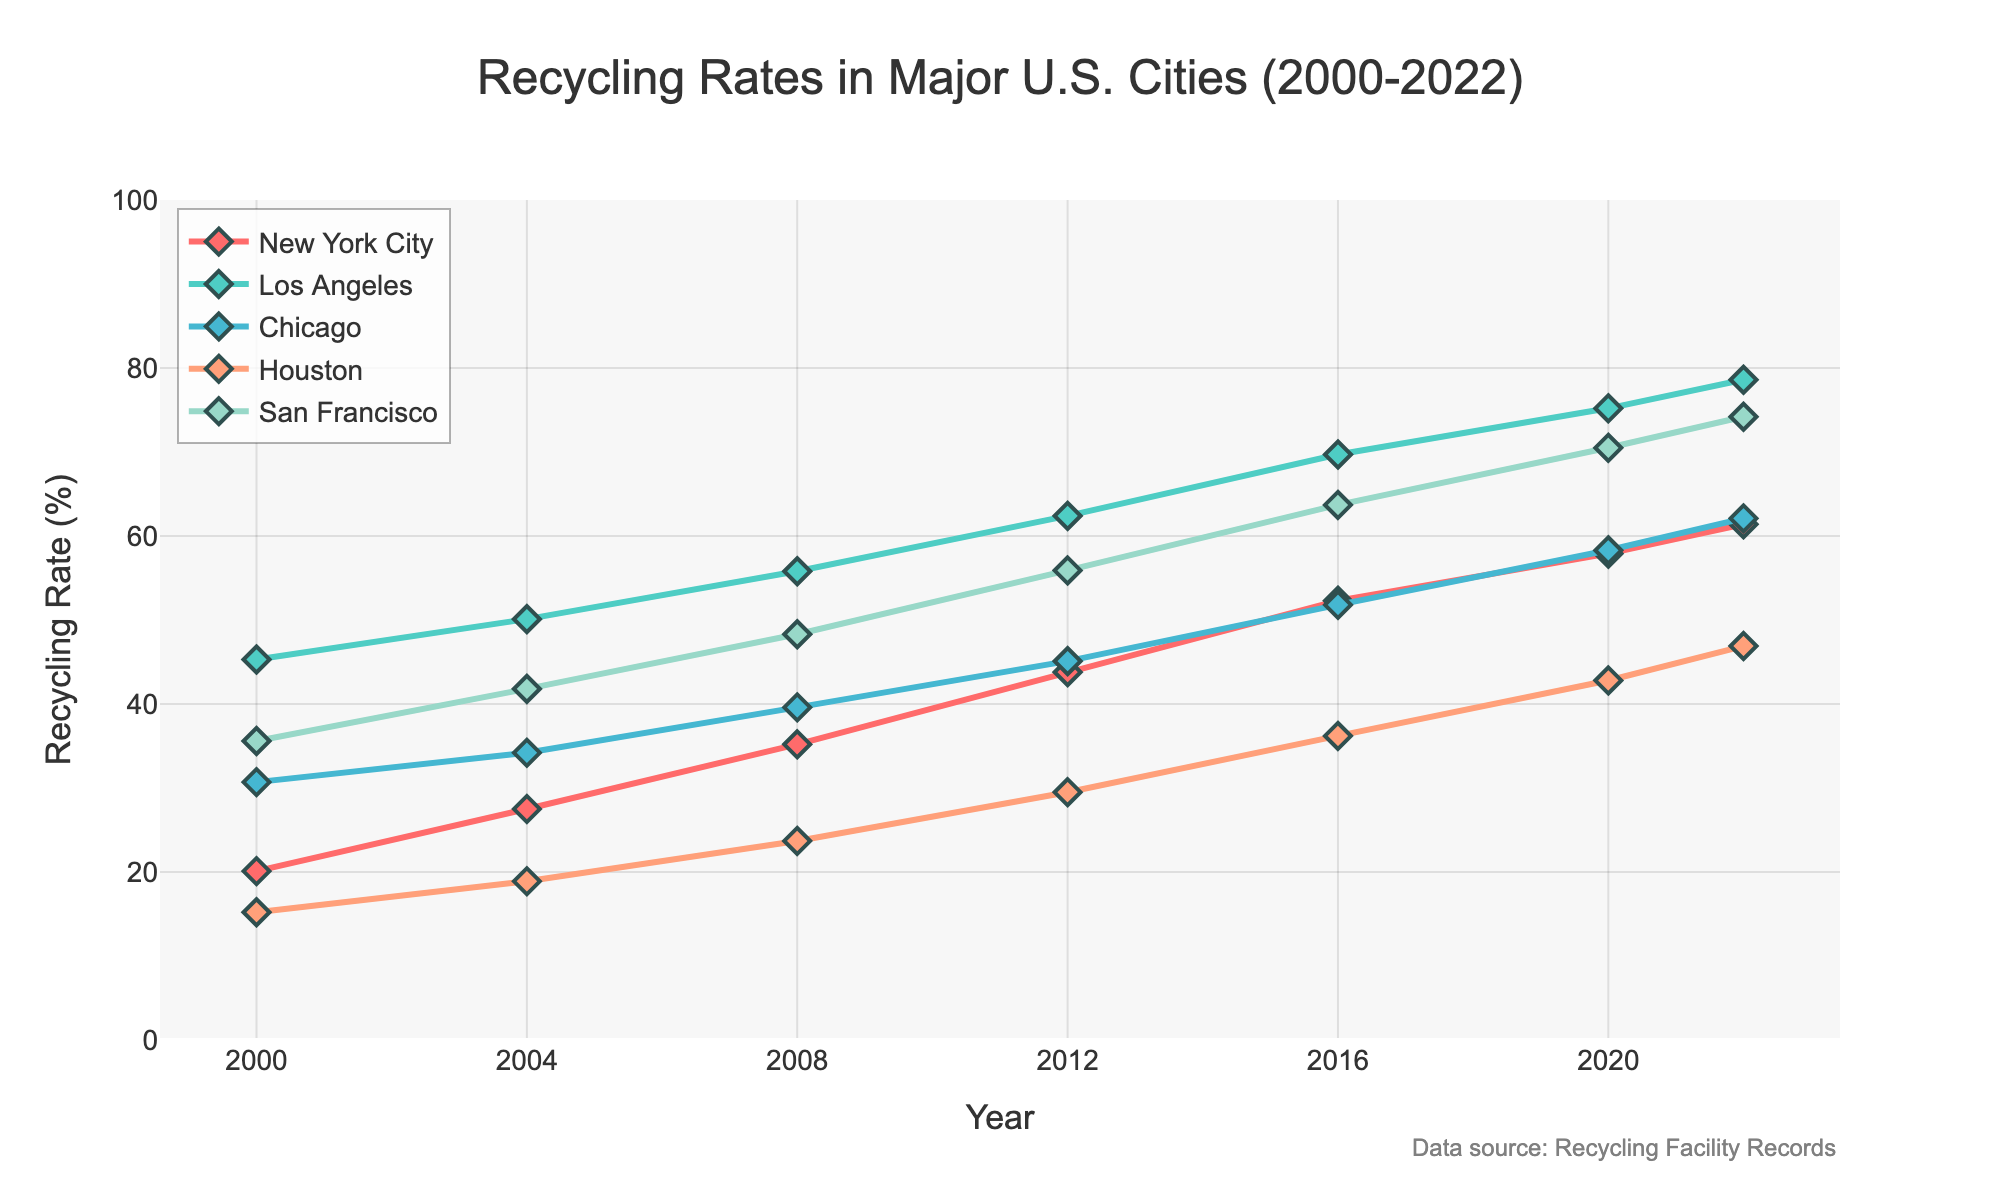What is the overall trend in recycling rates for all cities from 2000 to 2022? By visually inspecting the lines representing each city from 2000 to 2022, we see that all lines are trending upwards, indicating an increasing recycling rate across the years for all cities.
Answer: Increasing Which city had the highest recycling rate in 2022? By looking at the endpoint of each city's line for the year 2022, San Francisco's line (blue-green) reaches the highest point among all, indicating the highest recycling rate.
Answer: San Francisco What is the difference in recycling rates between New York City and Houston in 2022? Locate the recycling rates for New York City and Houston in 2022 on the Y-axis, which are 61.4% and 46.9%, respectively. Subtract Houston's rate from New York City's: 61.4 - 46.9 = 14.5.
Answer: 14.5% How did the recycling rate for Los Angeles change from 2000 to 2008? Look at Los Angeles' recycling rate in 2000 and 2008, which are 45.3% and 55.8% respectively. Subtract the earlier rate from the later one: 55.8 - 45.3 = 10.5.
Answer: Increased by 10.5% Compare the recycling rate trends of Chicago and Houston from 2016 to 2022. Observe the lines for Chicago and Houston between 2016 and 2022. Chicago's rate increases from 51.8% to 62.1%, an increase of 10.3. Houston's rate increases from 36.2% to 46.9%, an increase of 10.7. Both cities have a similar upward trend with a slightly greater increase in Houston.
Answer: Both increased, Houston slightly more What is the average recycling rate for San Francisco from 2000 to 2022? Add up all the recycling rates for San Francisco from 2000 to 2022 (35.6 + 41.8 + 48.3 + 55.9 + 63.7 + 70.5 + 74.2 = 390.0) and divide by the number of years (7): 390.0 / 7 = 55.71.
Answer: 55.71% What year did New York City's recycling rate surpass 50%? Follow New York City's line until it first crosses the 50% mark on the Y-axis. This happens in 2016.
Answer: 2016 Which city's recycling rate increased the most between 2000 and 2022? Calculate the difference for each city from 2000 to 2022. NYC: 61.4 - 20.1 = 41.3, LA: 78.6 - 45.3 = 33.3, Chicago: 62.1 - 30.7 = 31.4, Houston: 46.9 - 15.2 = 31.7, SF: 74.2 - 35.6 = 38.6. New York City has the highest increase of 41.3.
Answer: New York City What color represents Chicago's recycling rate in the figure? Locate the line corresponding to Chicago, which is the third city listed and is represented in blue.
Answer: Blue In 2008, what is the difference between San Francisco's and New York City's recycling rates? Find the recycling rates for these cities in 2008: San Francisco (48.3%) and New York City (35.2%). Subtract the latter from the former: 48.3 - 35.2 = 13.1.
Answer: 13.1% 